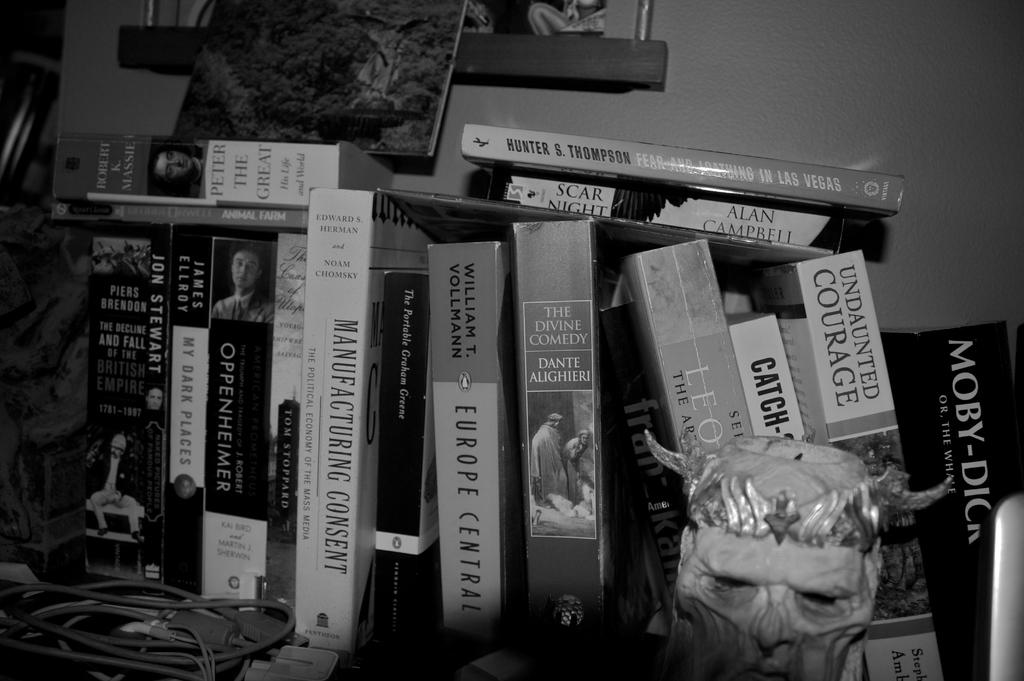<image>
Share a concise interpretation of the image provided. a black and white photo of a book collection that include the titles Europe Central, Scar Night, and MANUFACTURING CONSENT. 